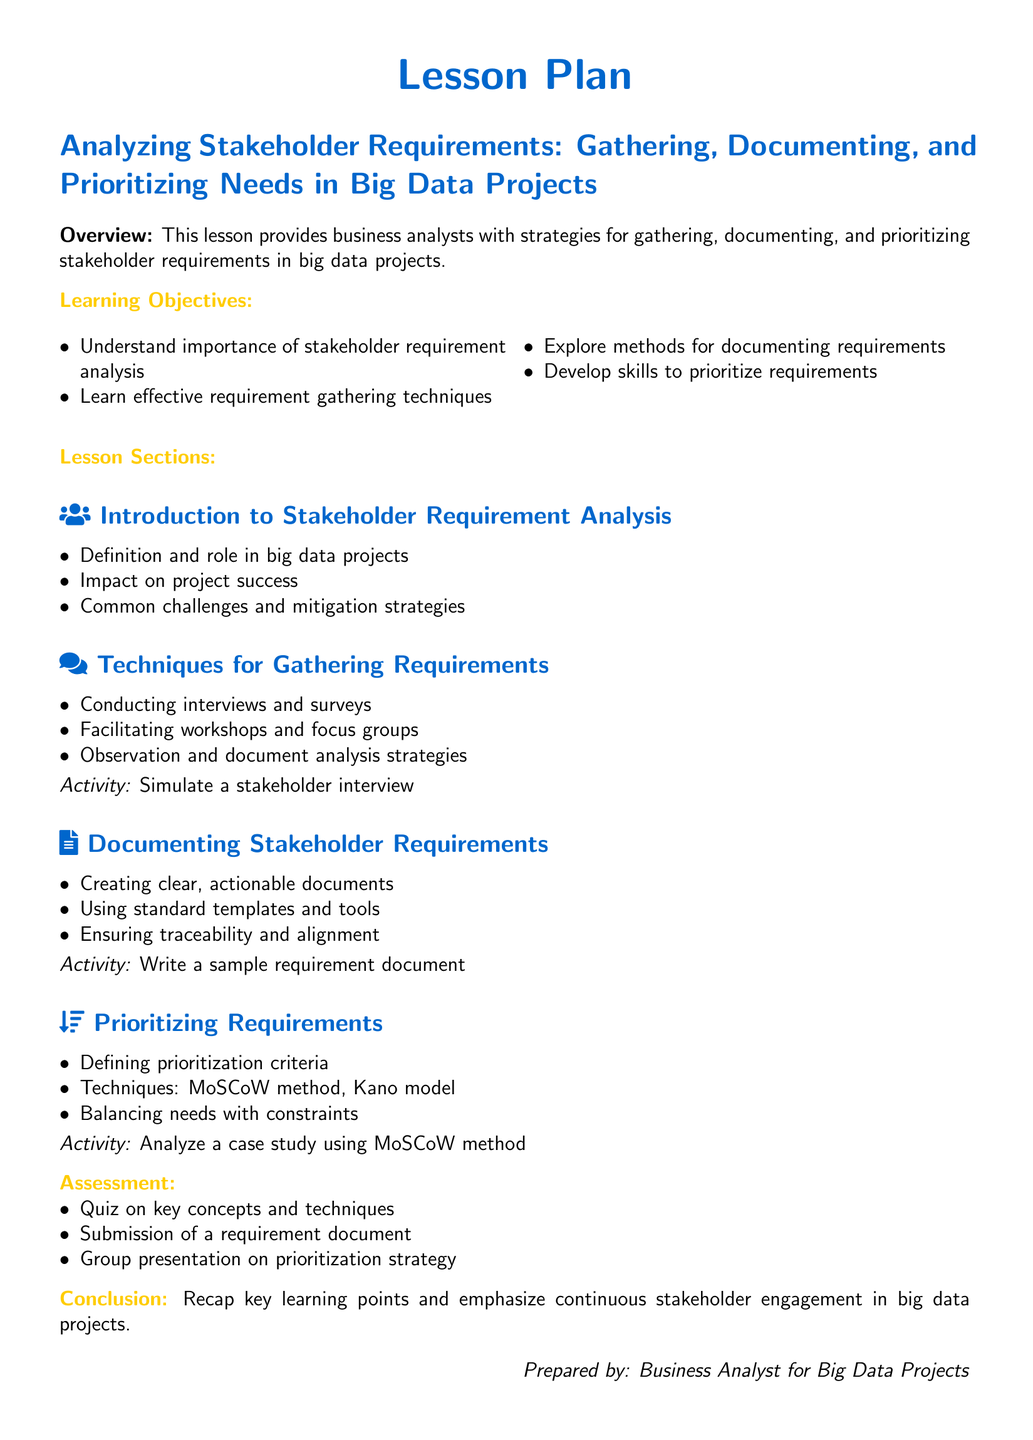what is the title of the lesson plan? The title of the lesson plan is clearly stated at the top of the document.
Answer: Analyzing Stakeholder Requirements: Gathering, Documenting, and Prioritizing Needs in Big Data Projects what are the learning objectives? The learning objectives are listed under the section labeled "Learning Objectives".
Answer: Understand importance of stakeholder requirement analysis, Learn effective requirement gathering techniques, Explore methods for documenting requirements, Develop skills to prioritize requirements what is one method for gathering requirements mentioned? The document outlines several techniques for gathering requirements under its respective section.
Answer: Conducting interviews and surveys what is the activity associated with documenting stakeholder requirements? An activity is specified in the section focusing on documenting stakeholder requirements.
Answer: Write a sample requirement document how many methods for prioritizing requirements are listed? The document explicitly mentions the techniques used for prioritizing requirements.
Answer: Two what is the name of the model mentioned in the prioritizing requirements section? The prioritizing requirements section references a specific model as part of its techniques.
Answer: Kano model what is the assessment activity regarding document submission? The assessment section includes specific activities related to evaluating student understanding.
Answer: Submission of a requirement document what does the conclusion emphasize? The conclusion summarizes the key learning points and presents a final thought.
Answer: Continuous stakeholder engagement in big data projects 